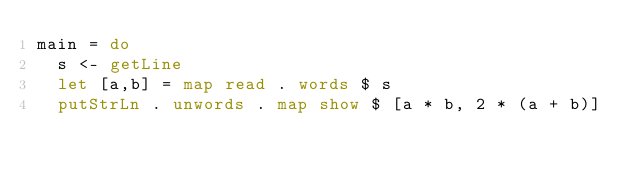<code> <loc_0><loc_0><loc_500><loc_500><_Haskell_>main = do
  s <- getLine
  let [a,b] = map read . words $ s
  putStrLn . unwords . map show $ [a * b, 2 * (a + b)]</code> 